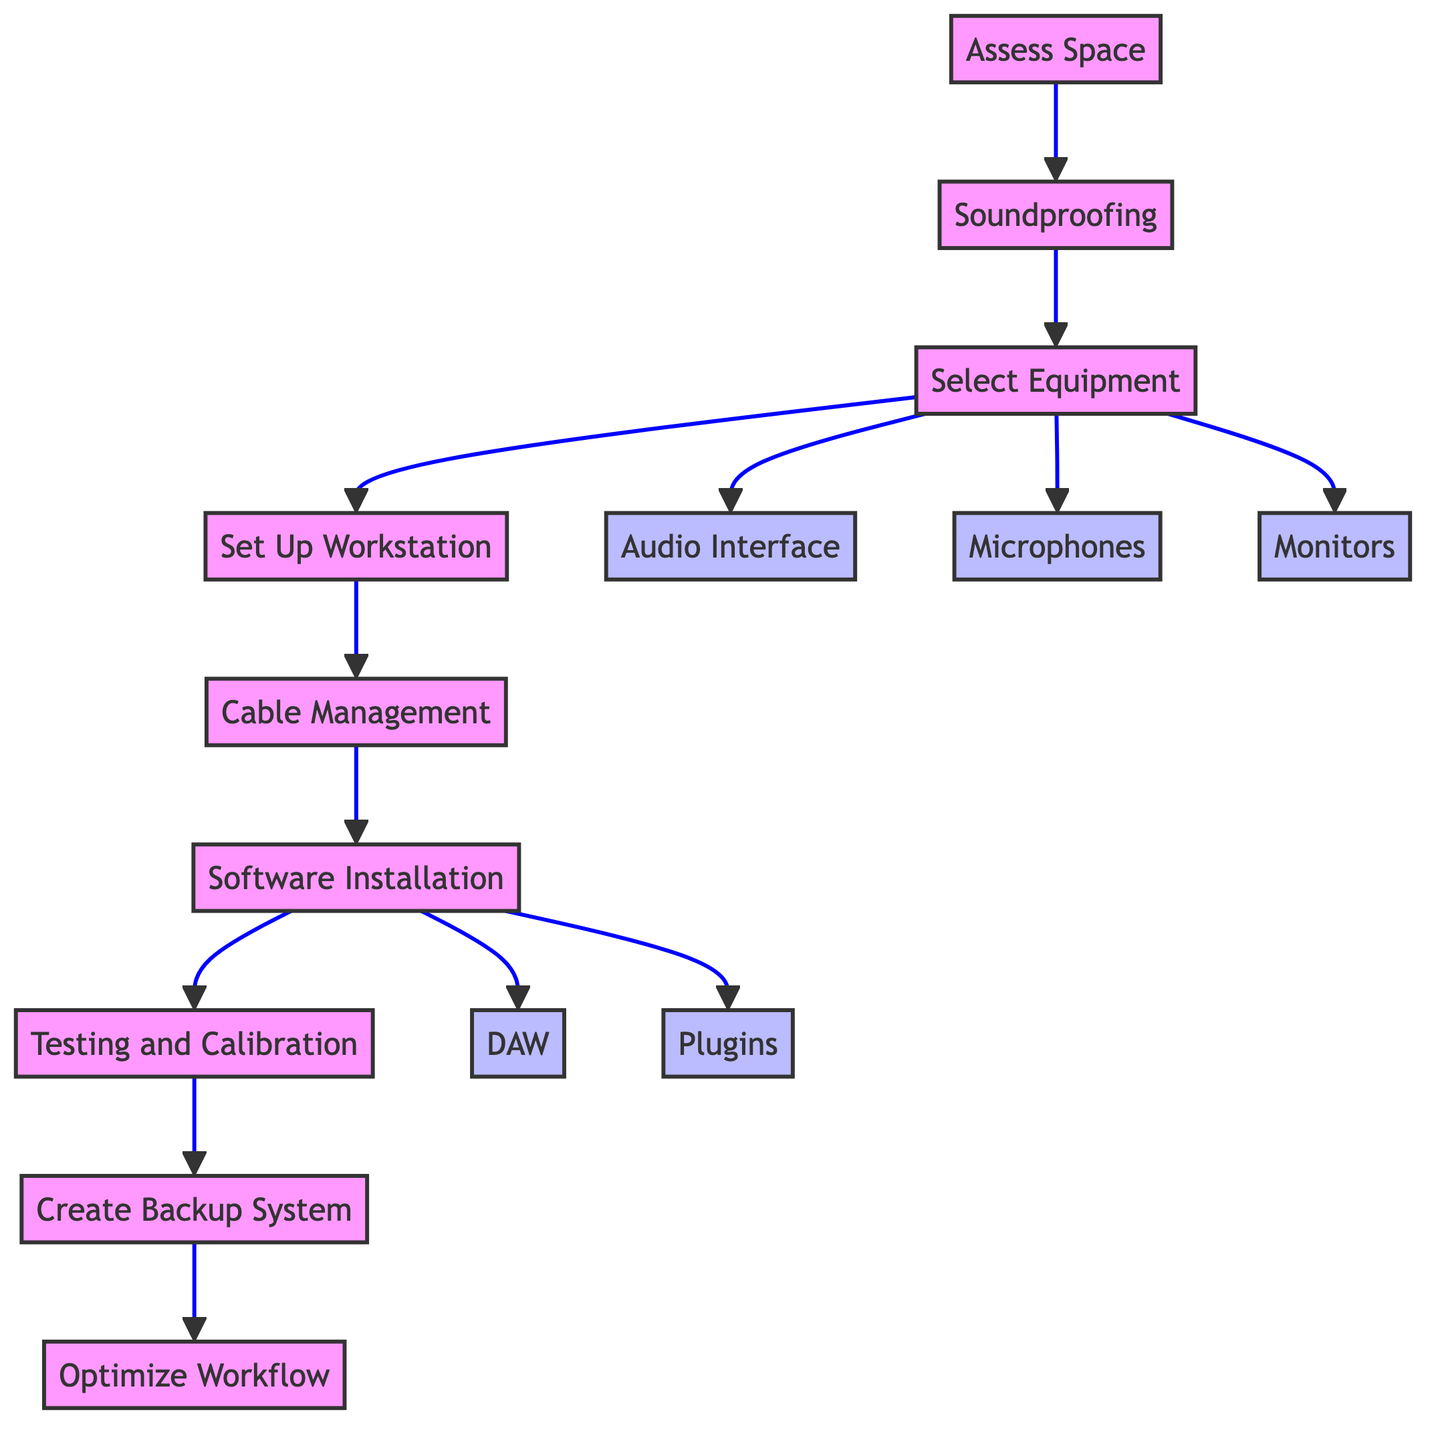What is the first step in the workflow? The first step indicated in the diagram is "Assess Space." This can be seen as the initial node in the flowchart leading to subsequent actions.
Answer: Assess Space How many main steps are there in the workflow? The flowchart consists of nine main steps, each representing a different phase in the home studio setup process, from "Assess Space" to "Optimize Workflow."
Answer: Nine What follows "Soundproofing" in the sequence? After "Soundproofing," the next step is "Select Equipment." This can be traced by following the arrows connecting the nodes in the flowchart.
Answer: Select Equipment What type of equipment should be selected after "Select Equipment"? After selecting equipment, the workflow specifies to choose "Audio Interface," "Microphones," and "Monitors." These are sub-steps branching off from the main "Select Equipment" node.
Answer: Audio Interface, Microphones, Monitors What is the function of the "Software Installation" step? The goal of "Software Installation" is to set up the necessary software for recording. This step includes sub-steps that specify installing a DAW and plugins to enhance the recording capability, making it a vital part of the workflow.
Answer: Install DAW and Plugins Which step comes directly after "Testing and Calibration"? The step that follows "Testing and Calibration" is "Create Backup System." This is confirmed by following the directional flow from one node to the next.
Answer: Create Backup System What two essential components are included in the software installation? The two essential components included in "Software Installation" are "DAW" and "Plugins." These are sub-components necessary for fully equipping the home studio for music creation.
Answer: DAW and Plugins What is the purpose of "Optimize Workflow"? The purpose of "Optimize Workflow" is to create an organized and efficient system for music creation by implementing software templates, presets, and custom mappings, illustrating the final step's focus on improved productivity.
Answer: Streamline music creation process Which element is directly related to sound management in the home studio? The element directly related to sound management is "Soundproofing," which focuses on the installation of acoustic treatments to control sound reflections and external noise.
Answer: Soundproofing 